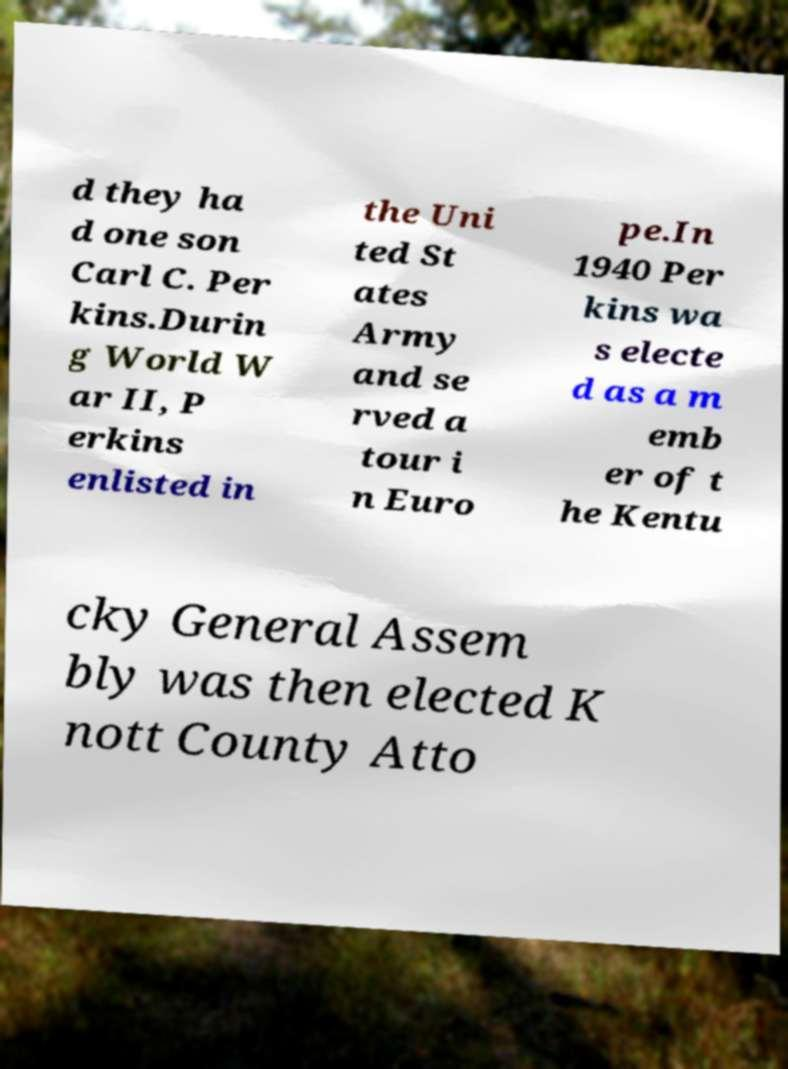There's text embedded in this image that I need extracted. Can you transcribe it verbatim? d they ha d one son Carl C. Per kins.Durin g World W ar II, P erkins enlisted in the Uni ted St ates Army and se rved a tour i n Euro pe.In 1940 Per kins wa s electe d as a m emb er of t he Kentu cky General Assem bly was then elected K nott County Atto 